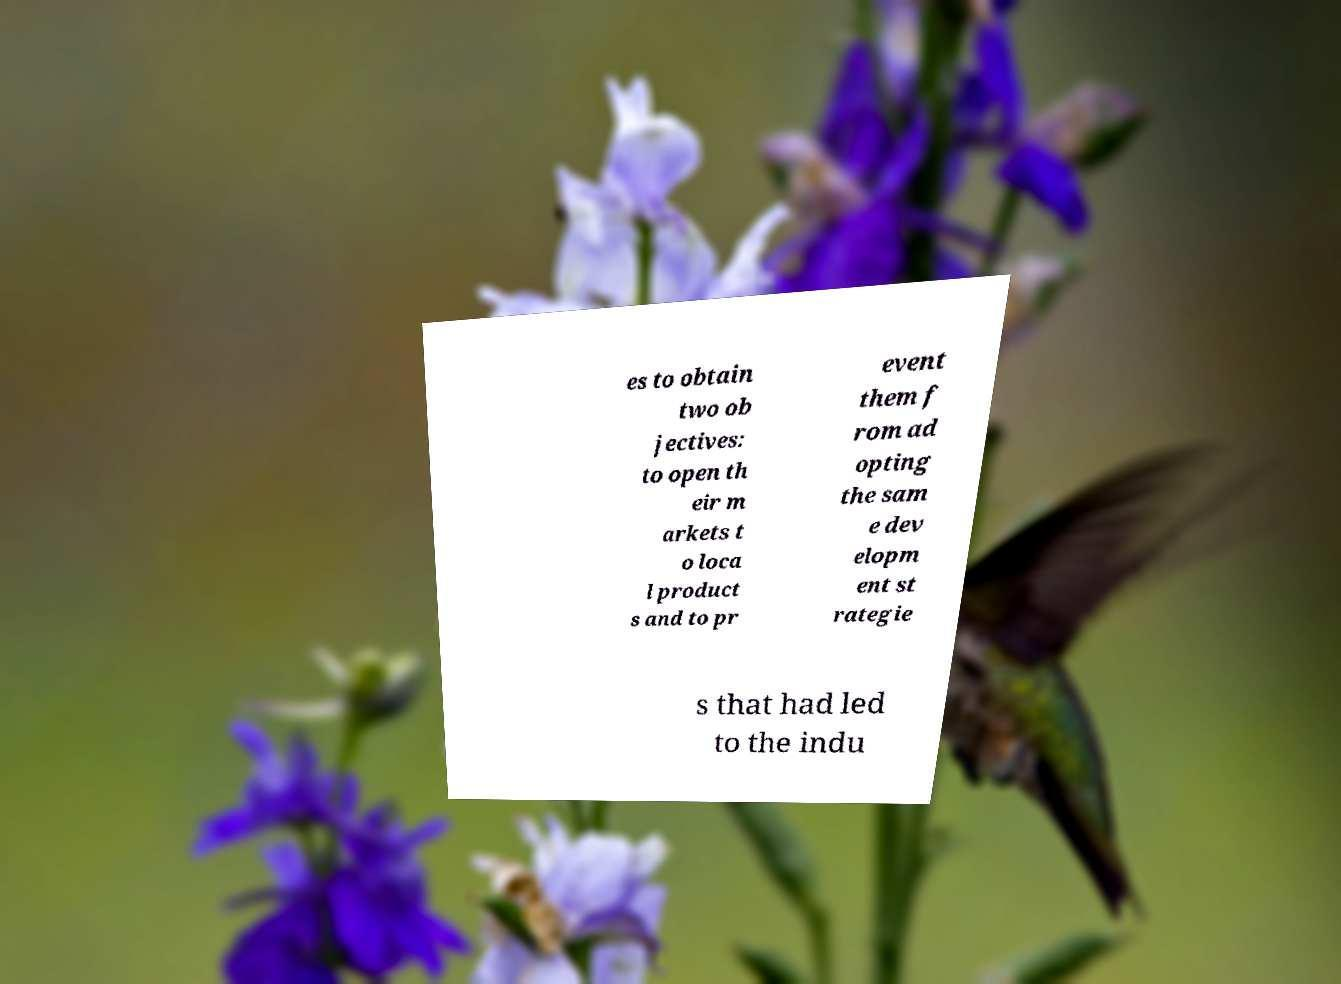Please identify and transcribe the text found in this image. es to obtain two ob jectives: to open th eir m arkets t o loca l product s and to pr event them f rom ad opting the sam e dev elopm ent st rategie s that had led to the indu 